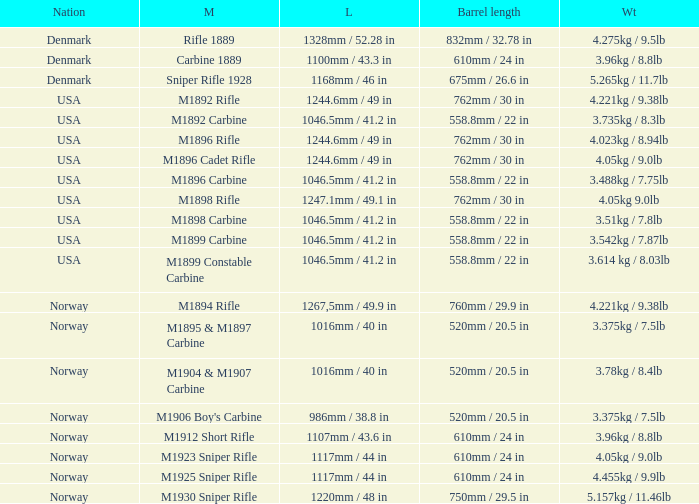What is Weight, when Length is 1168mm / 46 in? 5.265kg / 11.7lb. 